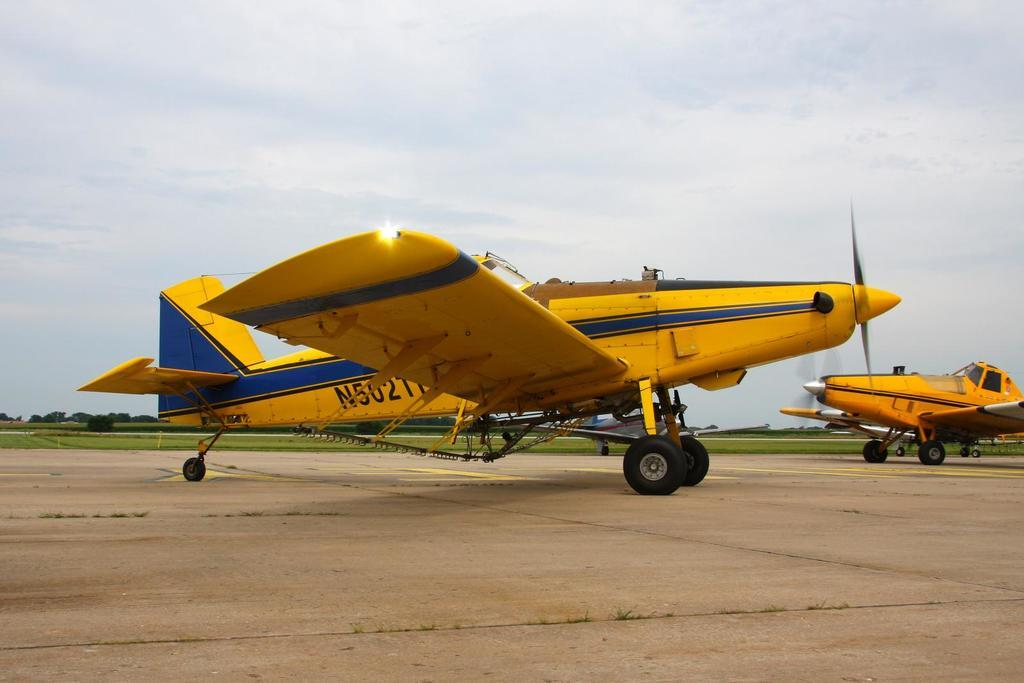<image>
Present a compact description of the photo's key features. An airplane whose call number starts with N5 sits on the runway. 